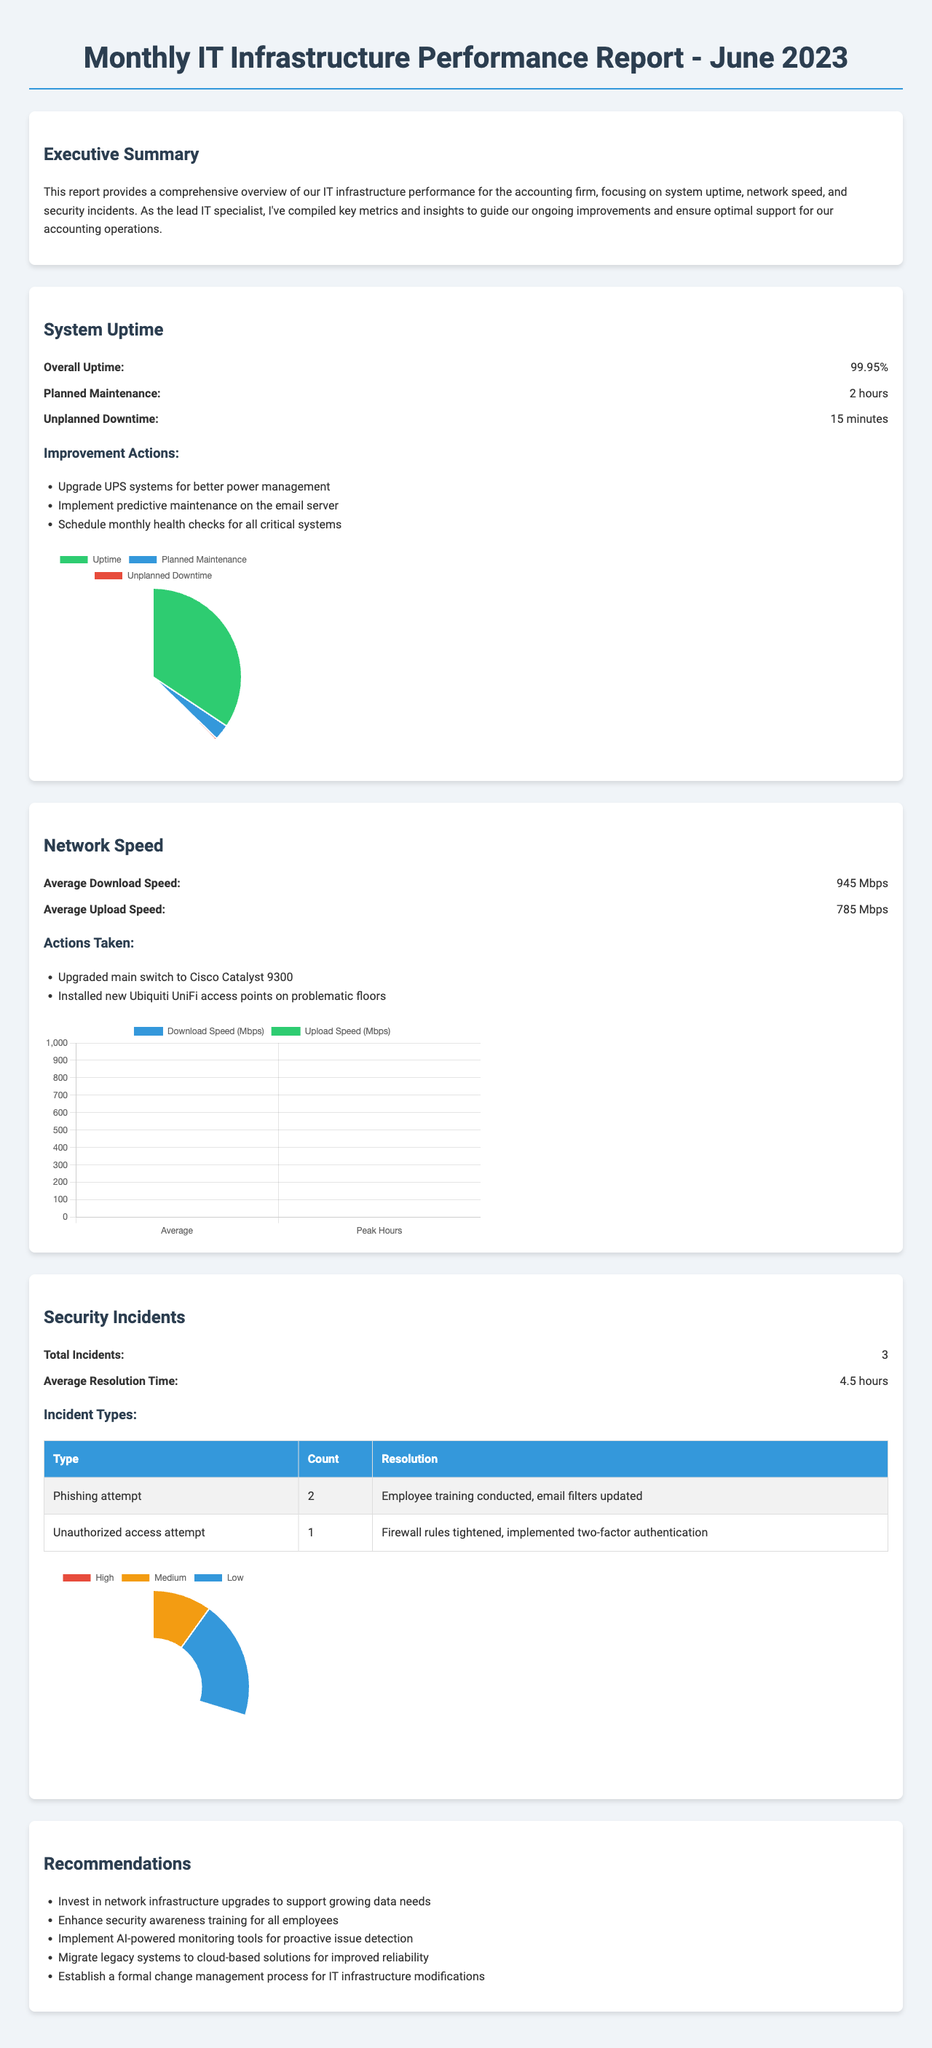What is the overall uptime percentage? The overall uptime percentage is specifically stated in the system uptime section of the report.
Answer: 99.95% What system was identified as the most reliable? The report mentions the most reliable system in the system uptime section.
Answer: Dell PowerEdge R740 File Server How many total security incidents were reported? The total incidents figure is given in the security incidents section of the document.
Answer: 3 What was the average download speed in Mbps? The average download speed is provided in the network speed section of the report.
Answer: 945 Mbps What improvement action is suggested for the email server? The improvement actions section mentions specific strategies to enhance the email server's performance.
Answer: Implement predictive maintenance on the email server What was the average resolution time for security incidents? The average resolution time is listed in the security incidents section of the report.
Answer: 4.5 hours What was the most updated software mentioned? The software updates section highlights which software has been updated most frequently.
Answer: QuickBooks Enterprise Which floor had the slowest network connection point? The report specifies where the slowest connection point is located in the network speed section.
Answer: 3rd floor, east wing How many user support tickets were created? The user support metrics section provides the total number of support tickets.
Answer: 127 